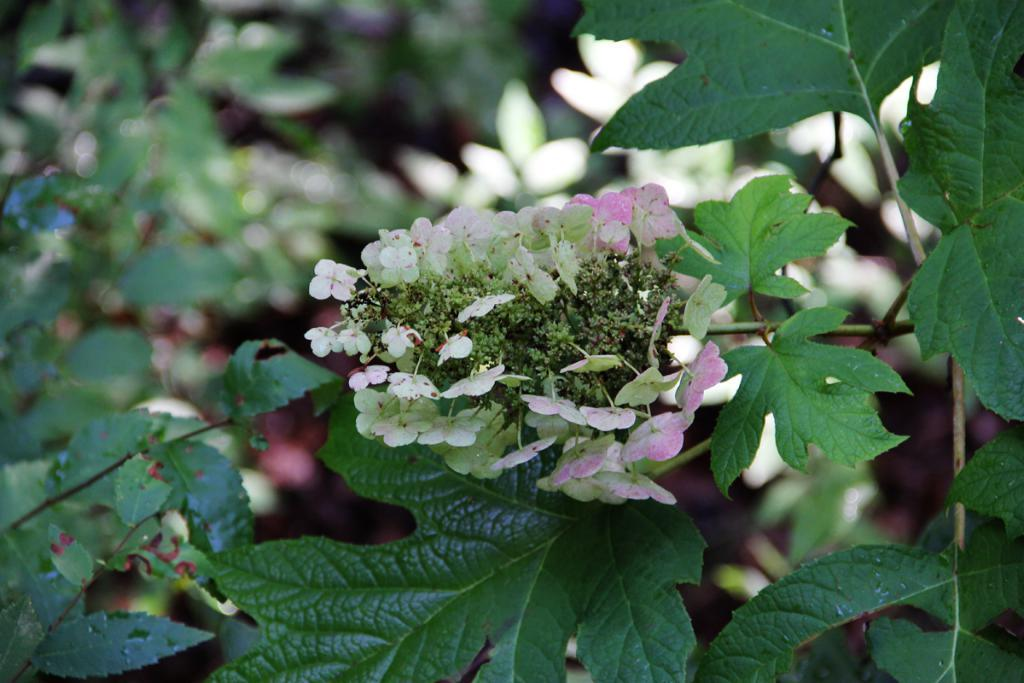What type of plant can be seen in the image? There is a flower plant in the image. Can you describe the background of the image? The background of the image is blurred. Reasoning: Let' Let's think step by step in order to produce the conversation. We start by identifying the main subject in the image, which is the flower plant. Then, we focus on the background of the image, noting that it is blurred. We avoid asking questions that cannot be answered definitively based on the provided facts. Absurd Question/Answer: How many cars are parked next to the flower plant in the image? There are no cars present in the image; it only features a flower plant and a blurred background. 